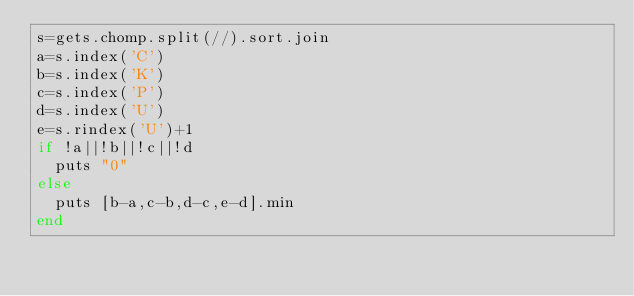Convert code to text. <code><loc_0><loc_0><loc_500><loc_500><_Ruby_>s=gets.chomp.split(//).sort.join
a=s.index('C')
b=s.index('K')
c=s.index('P')
d=s.index('U')
e=s.rindex('U')+1
if !a||!b||!c||!d
  puts "0"
else
  puts [b-a,c-b,d-c,e-d].min
end</code> 